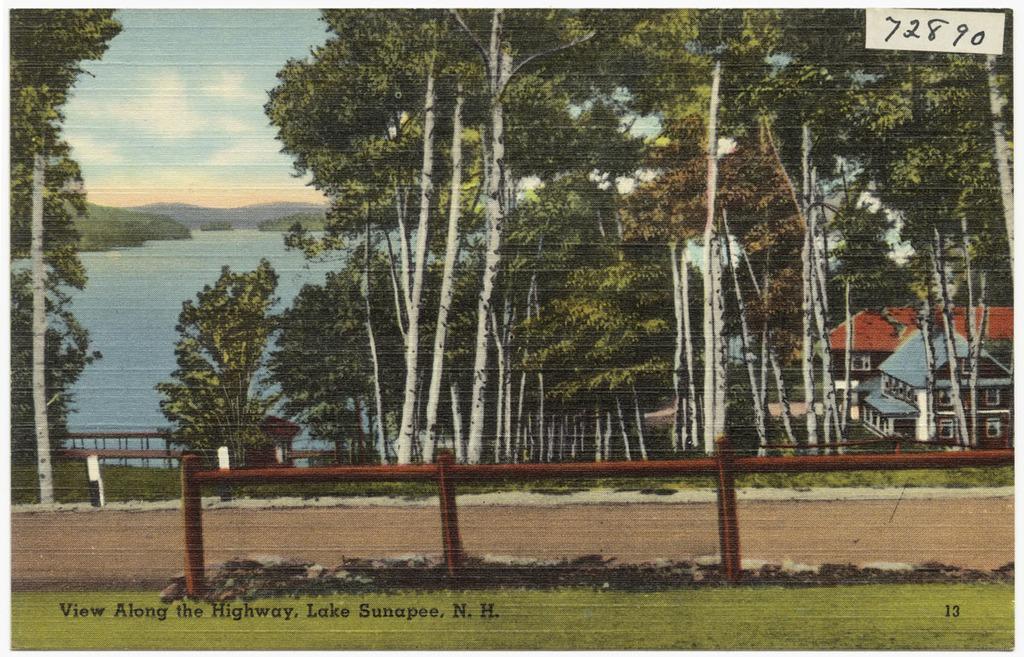Describe this image in one or two sentences. In the image we can see there is a cartoon image there are a lot of trees and beside there are buildings. On the other side there is a river and in front the ground is covered with grass. Beside it there is a road. 